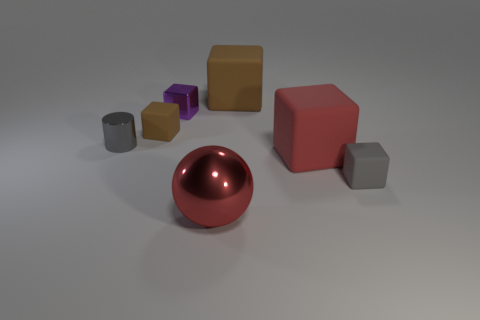Is the size of the purple cube the same as the red rubber thing?
Your answer should be compact. No. There is a large brown object that is the same shape as the gray rubber thing; what is its material?
Your answer should be very brief. Rubber. What number of red matte blocks have the same size as the gray metallic object?
Your answer should be very brief. 0. The cube that is made of the same material as the ball is what color?
Give a very brief answer. Purple. Is the number of brown things less than the number of blocks?
Make the answer very short. Yes. How many brown objects are either big metal things or big rubber cubes?
Keep it short and to the point. 1. How many things are both to the right of the small purple metal block and in front of the small brown rubber block?
Offer a very short reply. 3. Do the cylinder and the small purple block have the same material?
Your answer should be compact. Yes. What shape is the other metal thing that is the same size as the purple metal thing?
Your answer should be very brief. Cylinder. Is the number of tiny gray cubes greater than the number of brown metal objects?
Provide a succinct answer. Yes. 